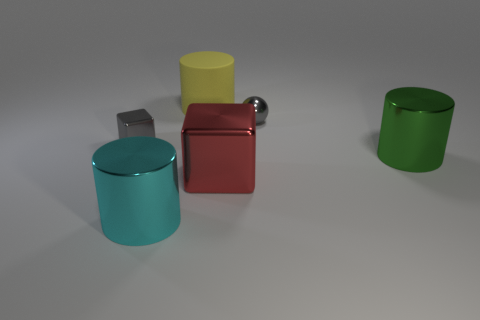Describe the lighting in the scene. The lighting in the scene is soft and diffuse, creating gentle shadows and subtle reflections on the surfaces of the objects. The light source appears to be positioned above the objects, allowing for a well-lit environment that highlights their shapes and colors. 